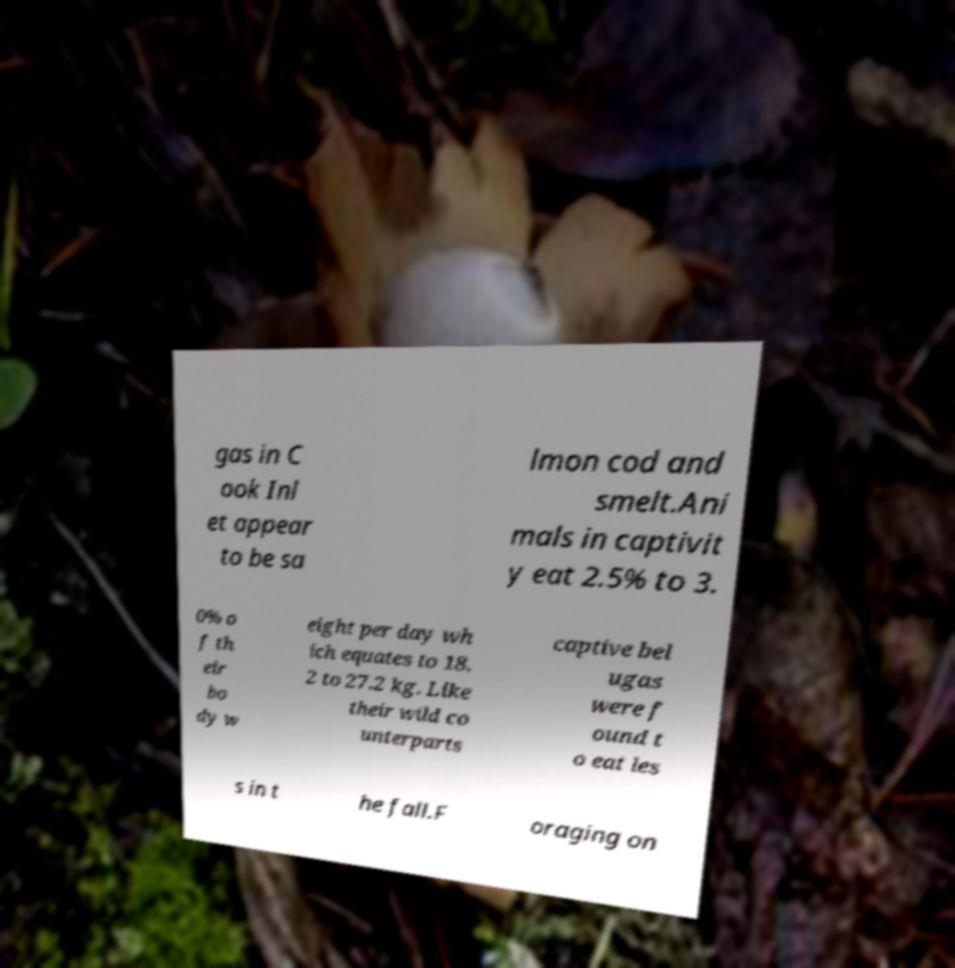Please read and relay the text visible in this image. What does it say? gas in C ook Inl et appear to be sa lmon cod and smelt.Ani mals in captivit y eat 2.5% to 3. 0% o f th eir bo dy w eight per day wh ich equates to 18. 2 to 27.2 kg. Like their wild co unterparts captive bel ugas were f ound t o eat les s in t he fall.F oraging on 